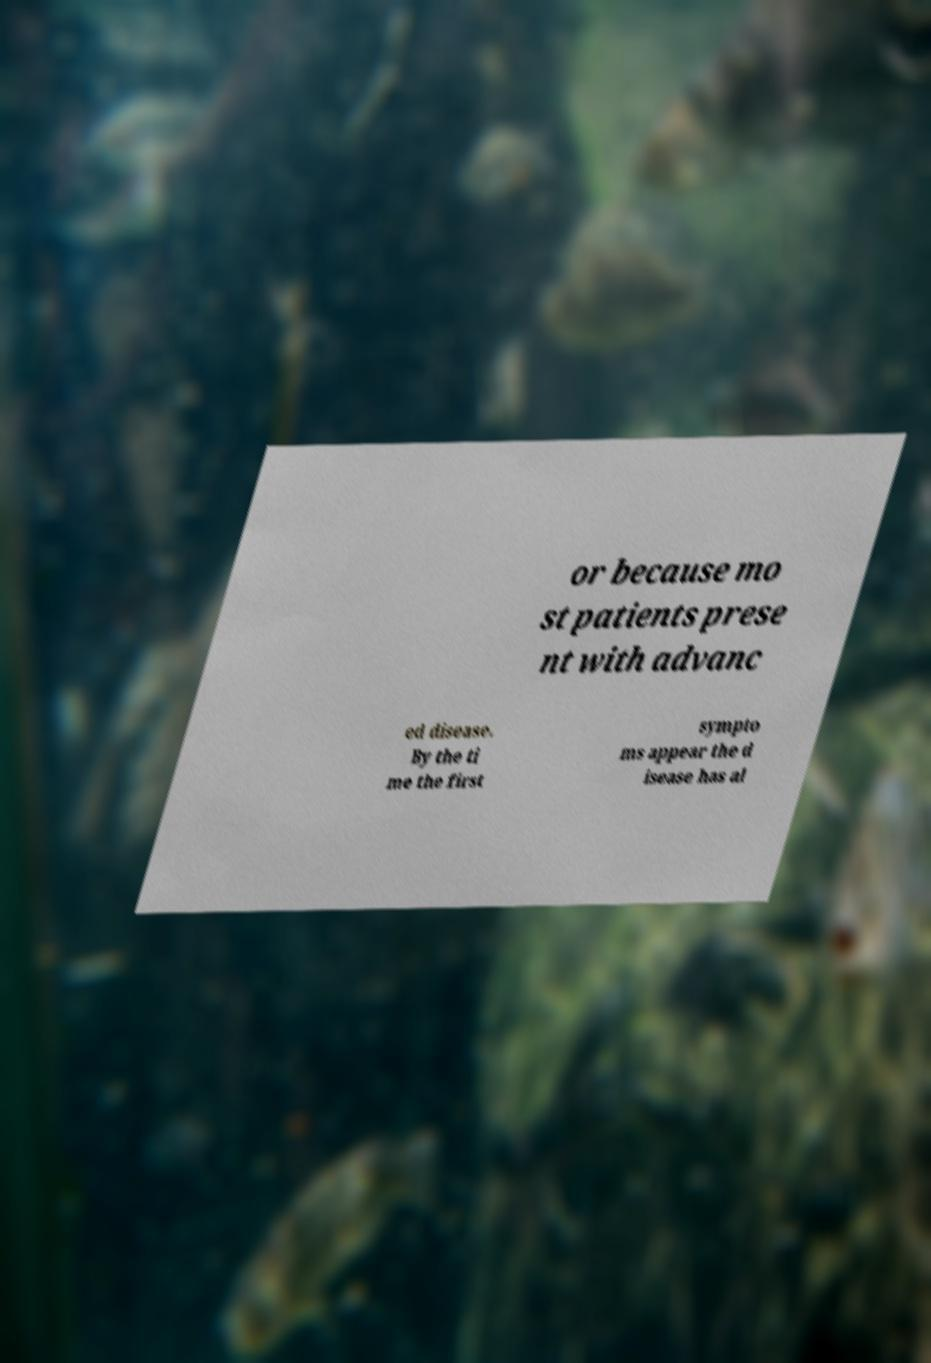What messages or text are displayed in this image? I need them in a readable, typed format. or because mo st patients prese nt with advanc ed disease. By the ti me the first sympto ms appear the d isease has al 